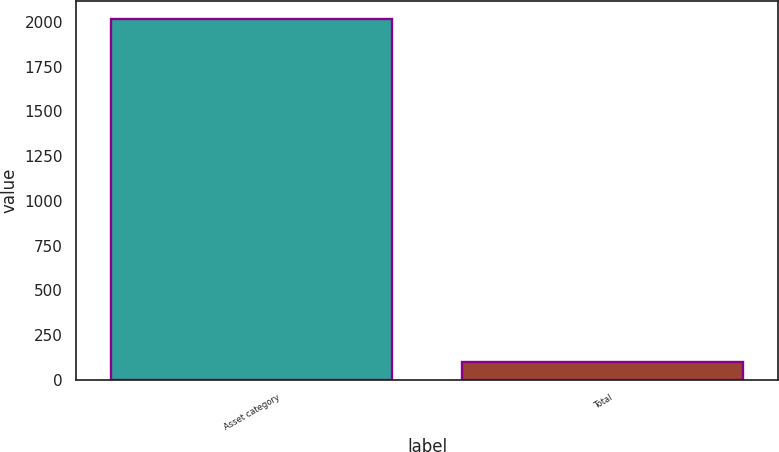<chart> <loc_0><loc_0><loc_500><loc_500><bar_chart><fcel>Asset category<fcel>Total<nl><fcel>2015<fcel>100<nl></chart> 